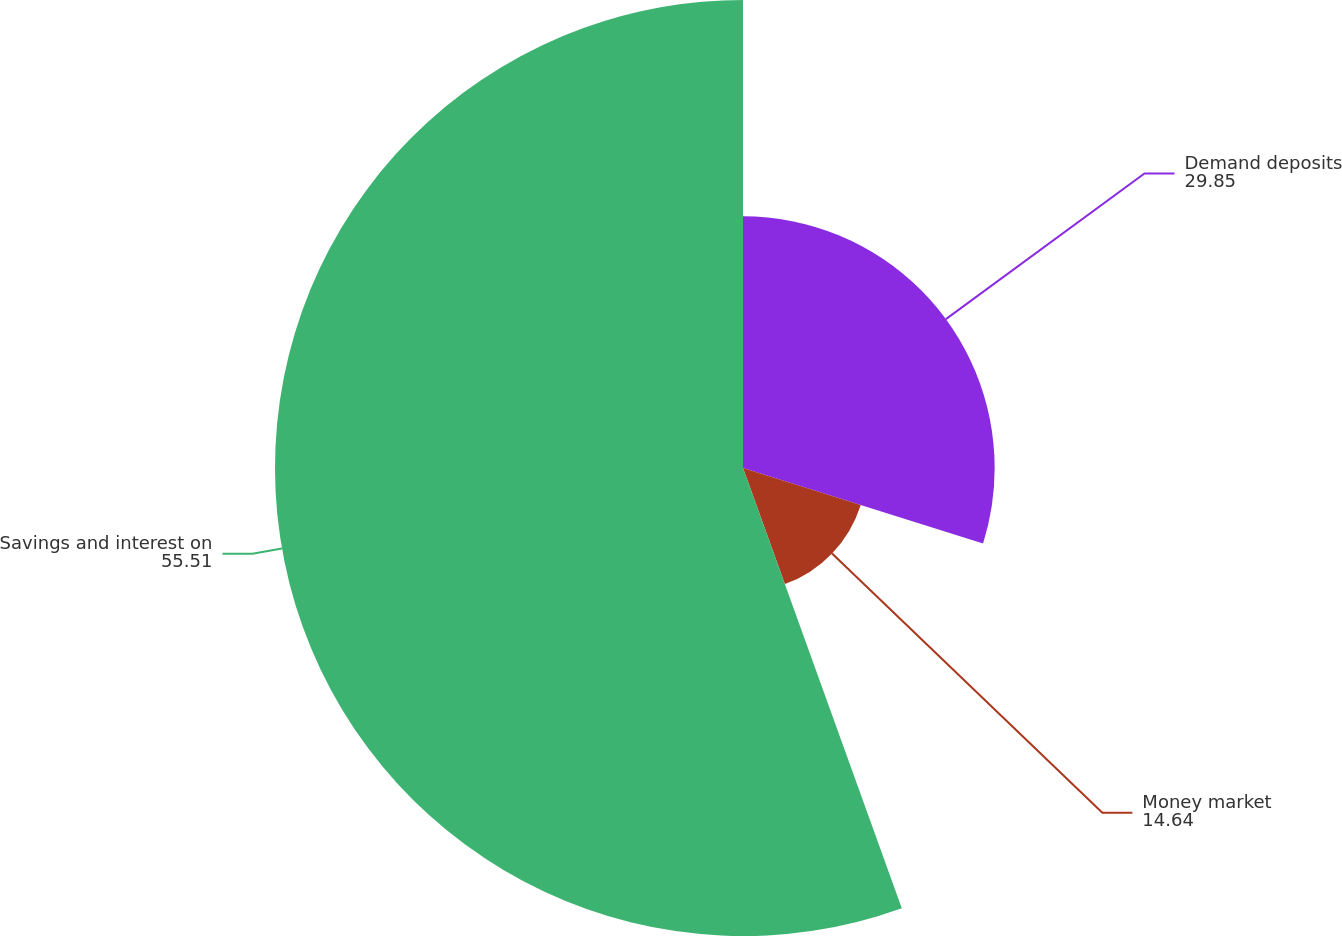Convert chart. <chart><loc_0><loc_0><loc_500><loc_500><pie_chart><fcel>Demand deposits<fcel>Money market<fcel>Savings and interest on<nl><fcel>29.85%<fcel>14.64%<fcel>55.51%<nl></chart> 